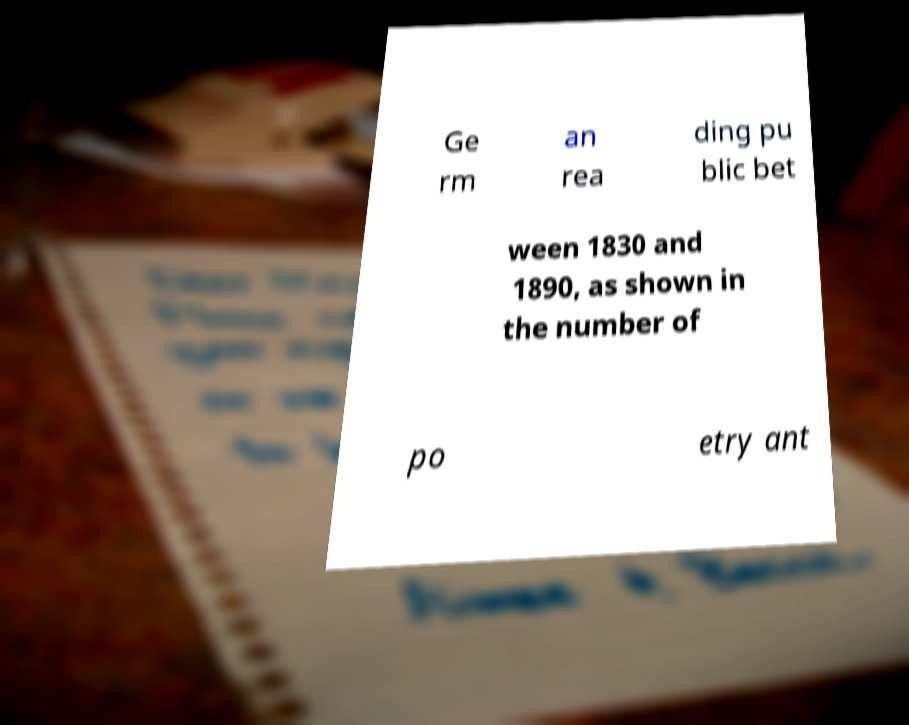What messages or text are displayed in this image? I need them in a readable, typed format. Ge rm an rea ding pu blic bet ween 1830 and 1890, as shown in the number of po etry ant 